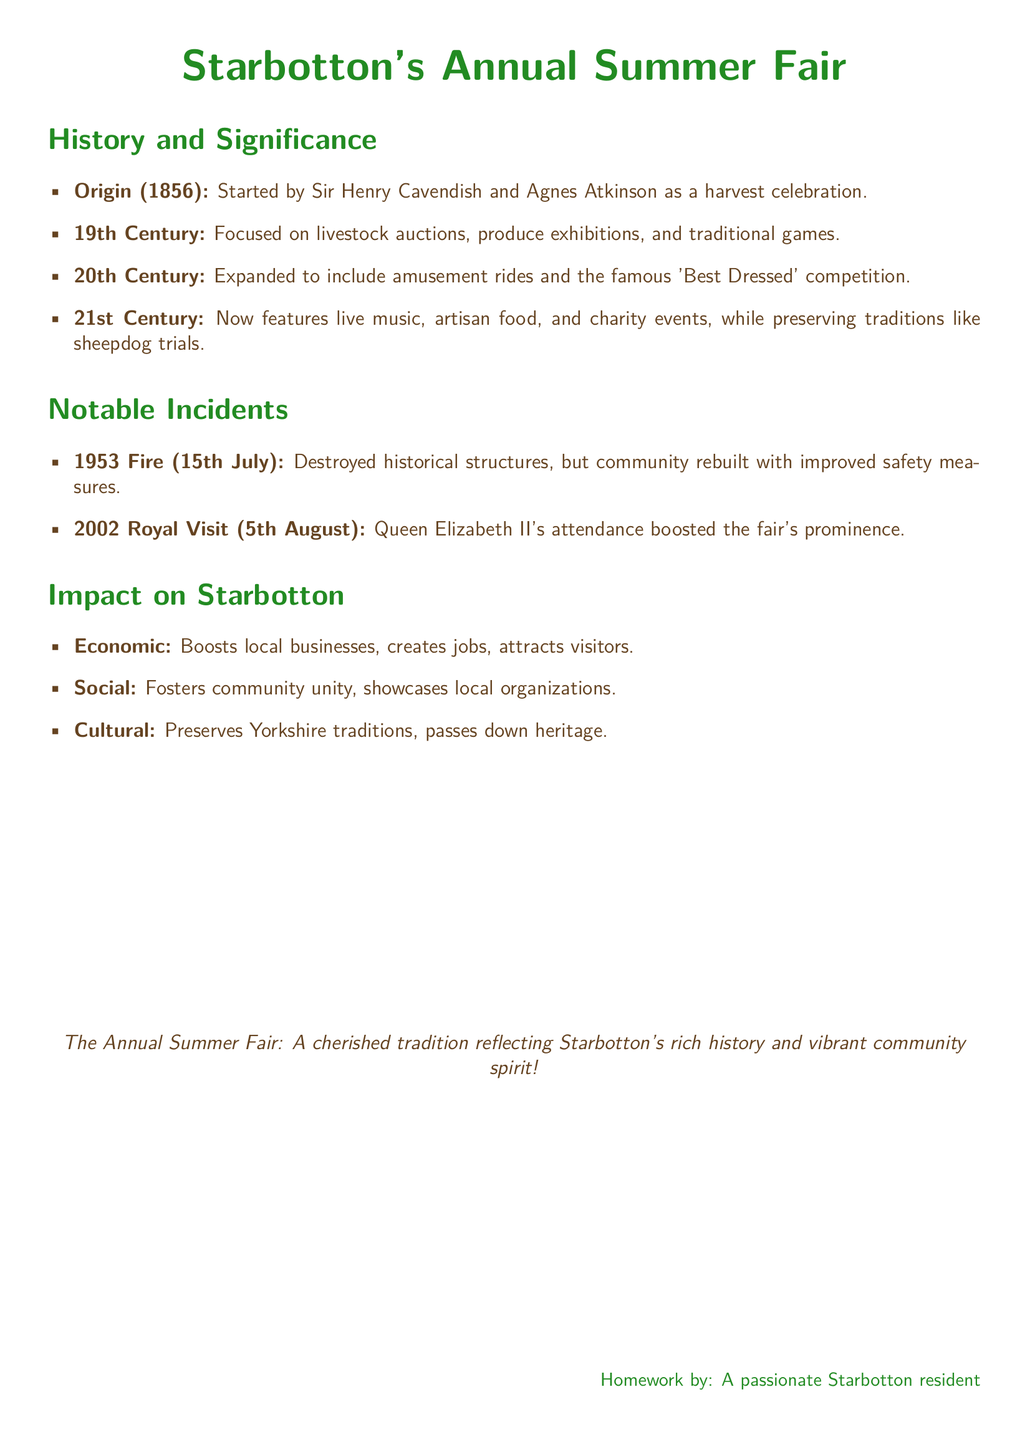What year did the Summer Fair start? The document states that the Summer Fair originated in 1856.
Answer: 1856 Who initiated the Summer Fair? The fair was started by Sir Henry Cavendish and Agnes Atkinson, as mentioned in the document.
Answer: Sir Henry Cavendish and Agnes Atkinson What significant incident occurred in 1953? The document mentions a fire that destroyed historical structures in 1953.
Answer: Fire Which royal attended the fair in 2002? According to the document, Queen Elizabeth II attended the fair, enhancing its prominence.
Answer: Queen Elizabeth II What type of competitions were present in the 20th century? The document mentions the famous 'Best Dressed' competition as part of the fair in the 20th century.
Answer: Best Dressed competition What is one economic impact of the Summer Fair on Starbotton? The document states that the fair boosts local businesses as one of its economic impacts.
Answer: Boosts local businesses What tradition does the fair preserve? The document highlights that the Summer Fair helps preserve Yorkshire traditions.
Answer: Yorkshire traditions In what century did the fair start featuring amusement rides? The document indicates that amusement rides were added in the 20th century.
Answer: 20th Century What type of events does the fair feature in the 21st century? The document lists live music, artisan food, and charity events as part of the 21st century fair.
Answer: Live music, artisan food, and charity events 